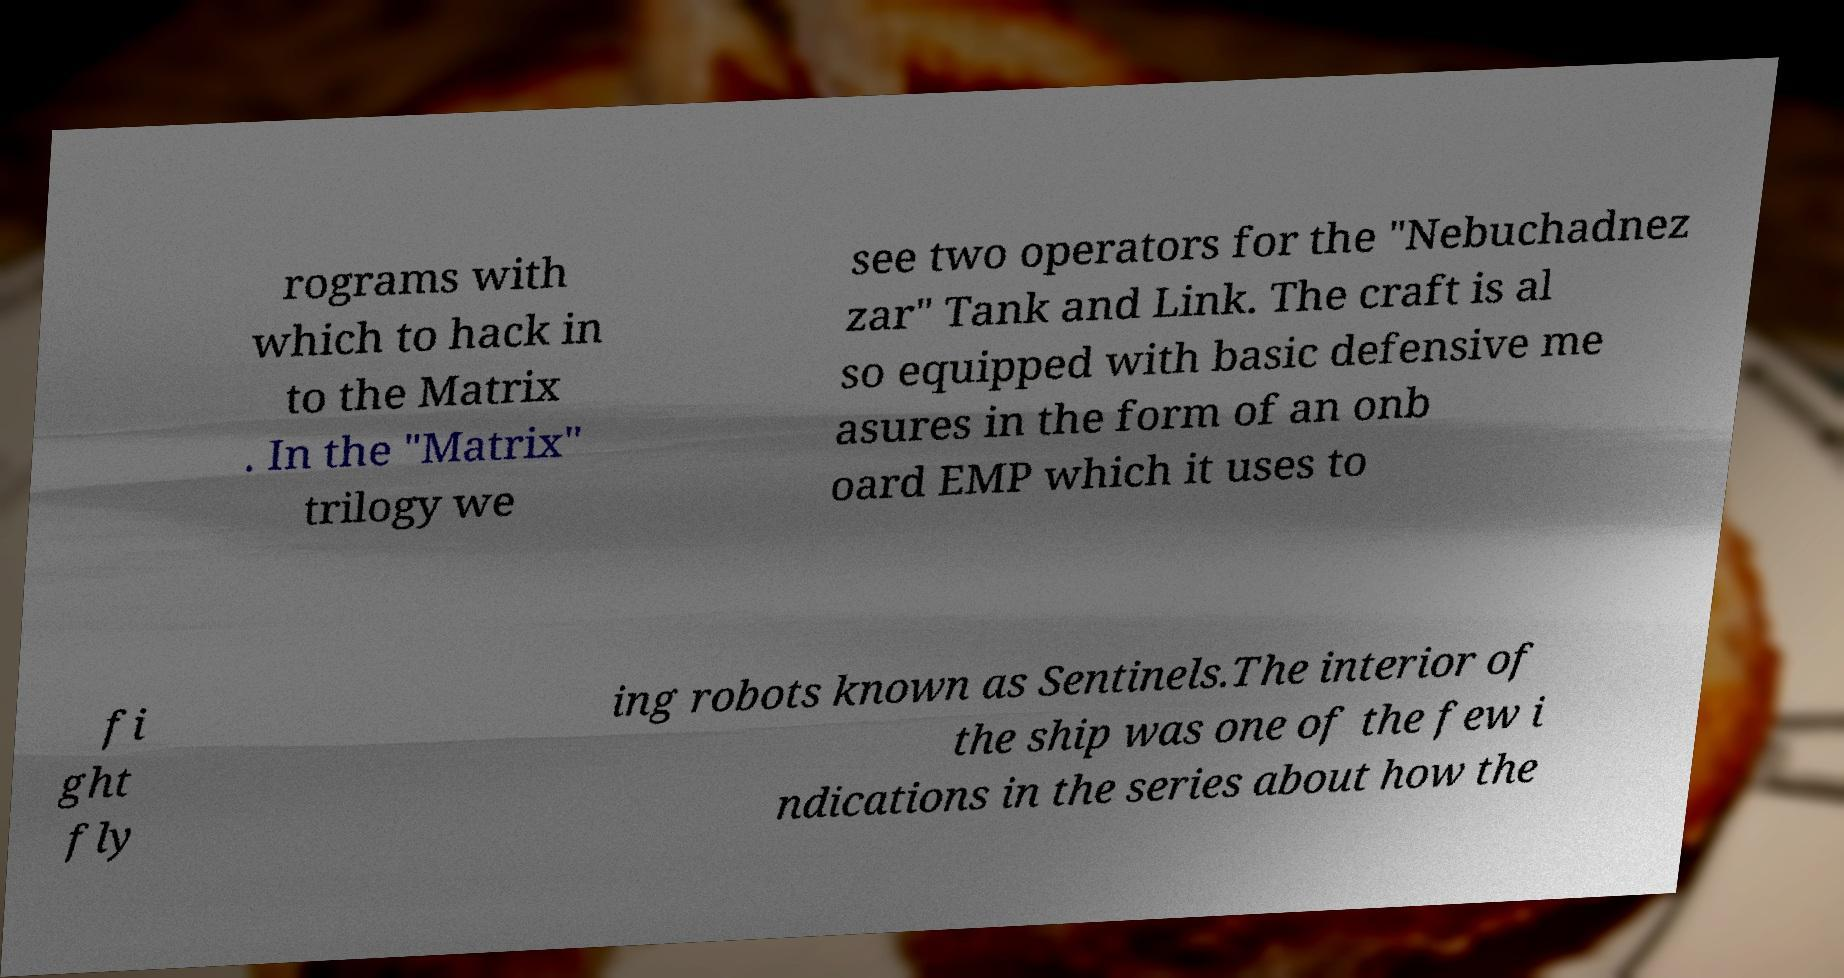What messages or text are displayed in this image? I need them in a readable, typed format. rograms with which to hack in to the Matrix . In the "Matrix" trilogy we see two operators for the "Nebuchadnez zar" Tank and Link. The craft is al so equipped with basic defensive me asures in the form of an onb oard EMP which it uses to fi ght fly ing robots known as Sentinels.The interior of the ship was one of the few i ndications in the series about how the 